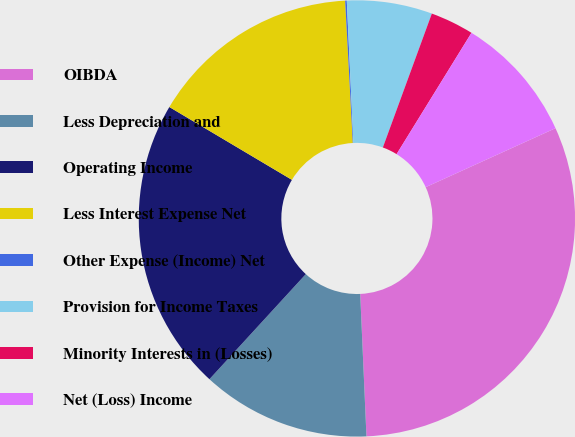Convert chart to OTSL. <chart><loc_0><loc_0><loc_500><loc_500><pie_chart><fcel>OIBDA<fcel>Less Depreciation and<fcel>Operating Income<fcel>Less Interest Expense Net<fcel>Other Expense (Income) Net<fcel>Provision for Income Taxes<fcel>Minority Interests in (Losses)<fcel>Net (Loss) Income<nl><fcel>31.09%<fcel>12.51%<fcel>21.72%<fcel>15.61%<fcel>0.12%<fcel>6.32%<fcel>3.22%<fcel>9.41%<nl></chart> 